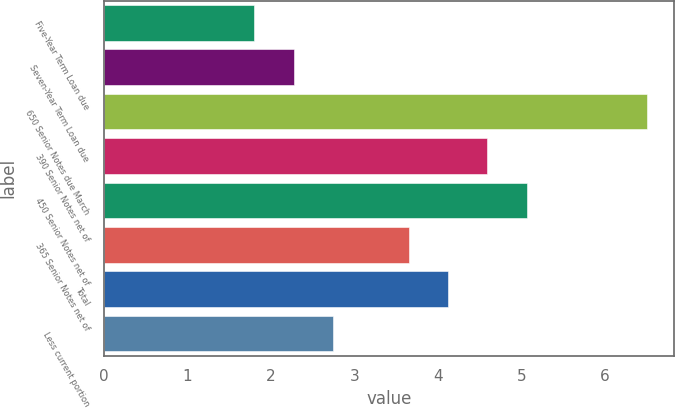Convert chart. <chart><loc_0><loc_0><loc_500><loc_500><bar_chart><fcel>Five-Year Term Loan due<fcel>Seven-Year Term Loan due<fcel>650 Senior Notes due March<fcel>390 Senior Notes net of<fcel>450 Senior Notes net of<fcel>365 Senior Notes net of<fcel>Total<fcel>Less current portion<nl><fcel>1.8<fcel>2.27<fcel>6.5<fcel>4.59<fcel>5.06<fcel>3.65<fcel>4.12<fcel>2.74<nl></chart> 